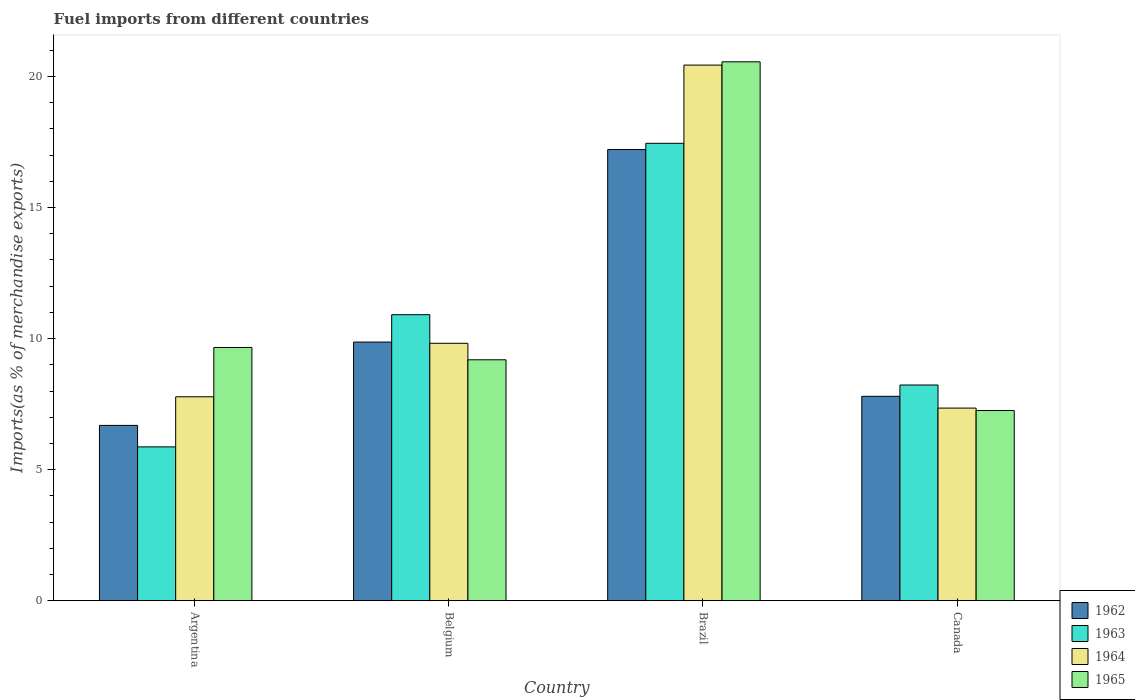How many different coloured bars are there?
Keep it short and to the point. 4. How many bars are there on the 4th tick from the left?
Offer a terse response. 4. What is the label of the 4th group of bars from the left?
Ensure brevity in your answer.  Canada. What is the percentage of imports to different countries in 1963 in Brazil?
Provide a succinct answer. 17.45. Across all countries, what is the maximum percentage of imports to different countries in 1965?
Your response must be concise. 20.55. Across all countries, what is the minimum percentage of imports to different countries in 1965?
Give a very brief answer. 7.26. What is the total percentage of imports to different countries in 1964 in the graph?
Keep it short and to the point. 45.38. What is the difference between the percentage of imports to different countries in 1964 in Argentina and that in Belgium?
Your response must be concise. -2.04. What is the difference between the percentage of imports to different countries in 1964 in Brazil and the percentage of imports to different countries in 1963 in Argentina?
Make the answer very short. 14.56. What is the average percentage of imports to different countries in 1964 per country?
Give a very brief answer. 11.34. What is the difference between the percentage of imports to different countries of/in 1963 and percentage of imports to different countries of/in 1964 in Belgium?
Make the answer very short. 1.09. What is the ratio of the percentage of imports to different countries in 1962 in Belgium to that in Canada?
Provide a short and direct response. 1.27. Is the percentage of imports to different countries in 1963 in Argentina less than that in Belgium?
Ensure brevity in your answer.  Yes. What is the difference between the highest and the second highest percentage of imports to different countries in 1965?
Provide a short and direct response. -10.89. What is the difference between the highest and the lowest percentage of imports to different countries in 1963?
Make the answer very short. 11.58. In how many countries, is the percentage of imports to different countries in 1962 greater than the average percentage of imports to different countries in 1962 taken over all countries?
Keep it short and to the point. 1. What does the 1st bar from the left in Brazil represents?
Provide a short and direct response. 1962. What does the 4th bar from the right in Belgium represents?
Your answer should be compact. 1962. Is it the case that in every country, the sum of the percentage of imports to different countries in 1964 and percentage of imports to different countries in 1965 is greater than the percentage of imports to different countries in 1962?
Provide a succinct answer. Yes. Are all the bars in the graph horizontal?
Give a very brief answer. No. What is the difference between two consecutive major ticks on the Y-axis?
Ensure brevity in your answer.  5. Are the values on the major ticks of Y-axis written in scientific E-notation?
Your answer should be compact. No. Does the graph contain grids?
Provide a short and direct response. No. How many legend labels are there?
Your answer should be very brief. 4. How are the legend labels stacked?
Make the answer very short. Vertical. What is the title of the graph?
Offer a very short reply. Fuel imports from different countries. What is the label or title of the X-axis?
Your response must be concise. Country. What is the label or title of the Y-axis?
Give a very brief answer. Imports(as % of merchandise exports). What is the Imports(as % of merchandise exports) of 1962 in Argentina?
Ensure brevity in your answer.  6.69. What is the Imports(as % of merchandise exports) in 1963 in Argentina?
Your answer should be compact. 5.87. What is the Imports(as % of merchandise exports) in 1964 in Argentina?
Keep it short and to the point. 7.78. What is the Imports(as % of merchandise exports) in 1965 in Argentina?
Your answer should be very brief. 9.66. What is the Imports(as % of merchandise exports) of 1962 in Belgium?
Provide a succinct answer. 9.87. What is the Imports(as % of merchandise exports) in 1963 in Belgium?
Your answer should be compact. 10.91. What is the Imports(as % of merchandise exports) of 1964 in Belgium?
Your answer should be very brief. 9.82. What is the Imports(as % of merchandise exports) in 1965 in Belgium?
Your answer should be compact. 9.19. What is the Imports(as % of merchandise exports) in 1962 in Brazil?
Provide a succinct answer. 17.21. What is the Imports(as % of merchandise exports) in 1963 in Brazil?
Provide a succinct answer. 17.45. What is the Imports(as % of merchandise exports) of 1964 in Brazil?
Your response must be concise. 20.43. What is the Imports(as % of merchandise exports) in 1965 in Brazil?
Offer a very short reply. 20.55. What is the Imports(as % of merchandise exports) in 1962 in Canada?
Offer a terse response. 7.8. What is the Imports(as % of merchandise exports) of 1963 in Canada?
Your answer should be compact. 8.23. What is the Imports(as % of merchandise exports) of 1964 in Canada?
Your answer should be very brief. 7.35. What is the Imports(as % of merchandise exports) in 1965 in Canada?
Keep it short and to the point. 7.26. Across all countries, what is the maximum Imports(as % of merchandise exports) in 1962?
Give a very brief answer. 17.21. Across all countries, what is the maximum Imports(as % of merchandise exports) in 1963?
Your response must be concise. 17.45. Across all countries, what is the maximum Imports(as % of merchandise exports) of 1964?
Your answer should be compact. 20.43. Across all countries, what is the maximum Imports(as % of merchandise exports) of 1965?
Ensure brevity in your answer.  20.55. Across all countries, what is the minimum Imports(as % of merchandise exports) of 1962?
Make the answer very short. 6.69. Across all countries, what is the minimum Imports(as % of merchandise exports) of 1963?
Ensure brevity in your answer.  5.87. Across all countries, what is the minimum Imports(as % of merchandise exports) of 1964?
Provide a succinct answer. 7.35. Across all countries, what is the minimum Imports(as % of merchandise exports) in 1965?
Keep it short and to the point. 7.26. What is the total Imports(as % of merchandise exports) of 1962 in the graph?
Ensure brevity in your answer.  41.56. What is the total Imports(as % of merchandise exports) of 1963 in the graph?
Provide a succinct answer. 42.46. What is the total Imports(as % of merchandise exports) of 1964 in the graph?
Your answer should be compact. 45.38. What is the total Imports(as % of merchandise exports) in 1965 in the graph?
Keep it short and to the point. 46.66. What is the difference between the Imports(as % of merchandise exports) in 1962 in Argentina and that in Belgium?
Your answer should be compact. -3.18. What is the difference between the Imports(as % of merchandise exports) in 1963 in Argentina and that in Belgium?
Provide a succinct answer. -5.04. What is the difference between the Imports(as % of merchandise exports) in 1964 in Argentina and that in Belgium?
Ensure brevity in your answer.  -2.04. What is the difference between the Imports(as % of merchandise exports) of 1965 in Argentina and that in Belgium?
Your answer should be compact. 0.47. What is the difference between the Imports(as % of merchandise exports) of 1962 in Argentina and that in Brazil?
Provide a short and direct response. -10.52. What is the difference between the Imports(as % of merchandise exports) in 1963 in Argentina and that in Brazil?
Your answer should be very brief. -11.58. What is the difference between the Imports(as % of merchandise exports) of 1964 in Argentina and that in Brazil?
Provide a succinct answer. -12.65. What is the difference between the Imports(as % of merchandise exports) in 1965 in Argentina and that in Brazil?
Provide a short and direct response. -10.89. What is the difference between the Imports(as % of merchandise exports) in 1962 in Argentina and that in Canada?
Provide a succinct answer. -1.11. What is the difference between the Imports(as % of merchandise exports) of 1963 in Argentina and that in Canada?
Provide a succinct answer. -2.36. What is the difference between the Imports(as % of merchandise exports) of 1964 in Argentina and that in Canada?
Keep it short and to the point. 0.43. What is the difference between the Imports(as % of merchandise exports) of 1965 in Argentina and that in Canada?
Offer a very short reply. 2.4. What is the difference between the Imports(as % of merchandise exports) in 1962 in Belgium and that in Brazil?
Make the answer very short. -7.34. What is the difference between the Imports(as % of merchandise exports) in 1963 in Belgium and that in Brazil?
Offer a terse response. -6.54. What is the difference between the Imports(as % of merchandise exports) in 1964 in Belgium and that in Brazil?
Ensure brevity in your answer.  -10.61. What is the difference between the Imports(as % of merchandise exports) of 1965 in Belgium and that in Brazil?
Keep it short and to the point. -11.36. What is the difference between the Imports(as % of merchandise exports) in 1962 in Belgium and that in Canada?
Make the answer very short. 2.07. What is the difference between the Imports(as % of merchandise exports) in 1963 in Belgium and that in Canada?
Give a very brief answer. 2.68. What is the difference between the Imports(as % of merchandise exports) in 1964 in Belgium and that in Canada?
Make the answer very short. 2.47. What is the difference between the Imports(as % of merchandise exports) of 1965 in Belgium and that in Canada?
Make the answer very short. 1.93. What is the difference between the Imports(as % of merchandise exports) in 1962 in Brazil and that in Canada?
Your response must be concise. 9.41. What is the difference between the Imports(as % of merchandise exports) of 1963 in Brazil and that in Canada?
Provide a short and direct response. 9.22. What is the difference between the Imports(as % of merchandise exports) of 1964 in Brazil and that in Canada?
Keep it short and to the point. 13.08. What is the difference between the Imports(as % of merchandise exports) of 1965 in Brazil and that in Canada?
Provide a succinct answer. 13.3. What is the difference between the Imports(as % of merchandise exports) in 1962 in Argentina and the Imports(as % of merchandise exports) in 1963 in Belgium?
Make the answer very short. -4.22. What is the difference between the Imports(as % of merchandise exports) of 1962 in Argentina and the Imports(as % of merchandise exports) of 1964 in Belgium?
Your response must be concise. -3.13. What is the difference between the Imports(as % of merchandise exports) of 1962 in Argentina and the Imports(as % of merchandise exports) of 1965 in Belgium?
Provide a succinct answer. -2.5. What is the difference between the Imports(as % of merchandise exports) of 1963 in Argentina and the Imports(as % of merchandise exports) of 1964 in Belgium?
Ensure brevity in your answer.  -3.95. What is the difference between the Imports(as % of merchandise exports) of 1963 in Argentina and the Imports(as % of merchandise exports) of 1965 in Belgium?
Provide a succinct answer. -3.32. What is the difference between the Imports(as % of merchandise exports) of 1964 in Argentina and the Imports(as % of merchandise exports) of 1965 in Belgium?
Make the answer very short. -1.41. What is the difference between the Imports(as % of merchandise exports) of 1962 in Argentina and the Imports(as % of merchandise exports) of 1963 in Brazil?
Your response must be concise. -10.76. What is the difference between the Imports(as % of merchandise exports) in 1962 in Argentina and the Imports(as % of merchandise exports) in 1964 in Brazil?
Give a very brief answer. -13.74. What is the difference between the Imports(as % of merchandise exports) of 1962 in Argentina and the Imports(as % of merchandise exports) of 1965 in Brazil?
Keep it short and to the point. -13.87. What is the difference between the Imports(as % of merchandise exports) of 1963 in Argentina and the Imports(as % of merchandise exports) of 1964 in Brazil?
Your answer should be very brief. -14.56. What is the difference between the Imports(as % of merchandise exports) in 1963 in Argentina and the Imports(as % of merchandise exports) in 1965 in Brazil?
Give a very brief answer. -14.68. What is the difference between the Imports(as % of merchandise exports) in 1964 in Argentina and the Imports(as % of merchandise exports) in 1965 in Brazil?
Your response must be concise. -12.77. What is the difference between the Imports(as % of merchandise exports) in 1962 in Argentina and the Imports(as % of merchandise exports) in 1963 in Canada?
Offer a very short reply. -1.54. What is the difference between the Imports(as % of merchandise exports) in 1962 in Argentina and the Imports(as % of merchandise exports) in 1964 in Canada?
Provide a short and direct response. -0.66. What is the difference between the Imports(as % of merchandise exports) in 1962 in Argentina and the Imports(as % of merchandise exports) in 1965 in Canada?
Give a very brief answer. -0.57. What is the difference between the Imports(as % of merchandise exports) of 1963 in Argentina and the Imports(as % of merchandise exports) of 1964 in Canada?
Your response must be concise. -1.48. What is the difference between the Imports(as % of merchandise exports) of 1963 in Argentina and the Imports(as % of merchandise exports) of 1965 in Canada?
Your answer should be compact. -1.39. What is the difference between the Imports(as % of merchandise exports) of 1964 in Argentina and the Imports(as % of merchandise exports) of 1965 in Canada?
Provide a succinct answer. 0.52. What is the difference between the Imports(as % of merchandise exports) of 1962 in Belgium and the Imports(as % of merchandise exports) of 1963 in Brazil?
Provide a short and direct response. -7.58. What is the difference between the Imports(as % of merchandise exports) of 1962 in Belgium and the Imports(as % of merchandise exports) of 1964 in Brazil?
Your response must be concise. -10.56. What is the difference between the Imports(as % of merchandise exports) of 1962 in Belgium and the Imports(as % of merchandise exports) of 1965 in Brazil?
Provide a short and direct response. -10.69. What is the difference between the Imports(as % of merchandise exports) of 1963 in Belgium and the Imports(as % of merchandise exports) of 1964 in Brazil?
Ensure brevity in your answer.  -9.52. What is the difference between the Imports(as % of merchandise exports) of 1963 in Belgium and the Imports(as % of merchandise exports) of 1965 in Brazil?
Your answer should be compact. -9.64. What is the difference between the Imports(as % of merchandise exports) in 1964 in Belgium and the Imports(as % of merchandise exports) in 1965 in Brazil?
Your answer should be very brief. -10.74. What is the difference between the Imports(as % of merchandise exports) of 1962 in Belgium and the Imports(as % of merchandise exports) of 1963 in Canada?
Provide a short and direct response. 1.64. What is the difference between the Imports(as % of merchandise exports) in 1962 in Belgium and the Imports(as % of merchandise exports) in 1964 in Canada?
Offer a very short reply. 2.52. What is the difference between the Imports(as % of merchandise exports) in 1962 in Belgium and the Imports(as % of merchandise exports) in 1965 in Canada?
Provide a short and direct response. 2.61. What is the difference between the Imports(as % of merchandise exports) of 1963 in Belgium and the Imports(as % of merchandise exports) of 1964 in Canada?
Your response must be concise. 3.56. What is the difference between the Imports(as % of merchandise exports) of 1963 in Belgium and the Imports(as % of merchandise exports) of 1965 in Canada?
Provide a short and direct response. 3.65. What is the difference between the Imports(as % of merchandise exports) of 1964 in Belgium and the Imports(as % of merchandise exports) of 1965 in Canada?
Offer a very short reply. 2.56. What is the difference between the Imports(as % of merchandise exports) of 1962 in Brazil and the Imports(as % of merchandise exports) of 1963 in Canada?
Your answer should be compact. 8.98. What is the difference between the Imports(as % of merchandise exports) of 1962 in Brazil and the Imports(as % of merchandise exports) of 1964 in Canada?
Give a very brief answer. 9.86. What is the difference between the Imports(as % of merchandise exports) in 1962 in Brazil and the Imports(as % of merchandise exports) in 1965 in Canada?
Keep it short and to the point. 9.95. What is the difference between the Imports(as % of merchandise exports) of 1963 in Brazil and the Imports(as % of merchandise exports) of 1964 in Canada?
Give a very brief answer. 10.1. What is the difference between the Imports(as % of merchandise exports) in 1963 in Brazil and the Imports(as % of merchandise exports) in 1965 in Canada?
Keep it short and to the point. 10.19. What is the difference between the Imports(as % of merchandise exports) of 1964 in Brazil and the Imports(as % of merchandise exports) of 1965 in Canada?
Your answer should be very brief. 13.17. What is the average Imports(as % of merchandise exports) in 1962 per country?
Your response must be concise. 10.39. What is the average Imports(as % of merchandise exports) in 1963 per country?
Keep it short and to the point. 10.61. What is the average Imports(as % of merchandise exports) in 1964 per country?
Your answer should be compact. 11.34. What is the average Imports(as % of merchandise exports) of 1965 per country?
Give a very brief answer. 11.67. What is the difference between the Imports(as % of merchandise exports) of 1962 and Imports(as % of merchandise exports) of 1963 in Argentina?
Provide a succinct answer. 0.82. What is the difference between the Imports(as % of merchandise exports) in 1962 and Imports(as % of merchandise exports) in 1964 in Argentina?
Offer a terse response. -1.09. What is the difference between the Imports(as % of merchandise exports) of 1962 and Imports(as % of merchandise exports) of 1965 in Argentina?
Your answer should be compact. -2.97. What is the difference between the Imports(as % of merchandise exports) in 1963 and Imports(as % of merchandise exports) in 1964 in Argentina?
Give a very brief answer. -1.91. What is the difference between the Imports(as % of merchandise exports) in 1963 and Imports(as % of merchandise exports) in 1965 in Argentina?
Offer a very short reply. -3.79. What is the difference between the Imports(as % of merchandise exports) of 1964 and Imports(as % of merchandise exports) of 1965 in Argentina?
Offer a terse response. -1.88. What is the difference between the Imports(as % of merchandise exports) in 1962 and Imports(as % of merchandise exports) in 1963 in Belgium?
Your response must be concise. -1.04. What is the difference between the Imports(as % of merchandise exports) in 1962 and Imports(as % of merchandise exports) in 1964 in Belgium?
Your answer should be compact. 0.05. What is the difference between the Imports(as % of merchandise exports) of 1962 and Imports(as % of merchandise exports) of 1965 in Belgium?
Your answer should be very brief. 0.68. What is the difference between the Imports(as % of merchandise exports) in 1963 and Imports(as % of merchandise exports) in 1964 in Belgium?
Offer a very short reply. 1.09. What is the difference between the Imports(as % of merchandise exports) in 1963 and Imports(as % of merchandise exports) in 1965 in Belgium?
Offer a very short reply. 1.72. What is the difference between the Imports(as % of merchandise exports) in 1964 and Imports(as % of merchandise exports) in 1965 in Belgium?
Your response must be concise. 0.63. What is the difference between the Imports(as % of merchandise exports) in 1962 and Imports(as % of merchandise exports) in 1963 in Brazil?
Make the answer very short. -0.24. What is the difference between the Imports(as % of merchandise exports) of 1962 and Imports(as % of merchandise exports) of 1964 in Brazil?
Your answer should be very brief. -3.22. What is the difference between the Imports(as % of merchandise exports) of 1962 and Imports(as % of merchandise exports) of 1965 in Brazil?
Give a very brief answer. -3.35. What is the difference between the Imports(as % of merchandise exports) in 1963 and Imports(as % of merchandise exports) in 1964 in Brazil?
Provide a short and direct response. -2.98. What is the difference between the Imports(as % of merchandise exports) of 1963 and Imports(as % of merchandise exports) of 1965 in Brazil?
Make the answer very short. -3.11. What is the difference between the Imports(as % of merchandise exports) of 1964 and Imports(as % of merchandise exports) of 1965 in Brazil?
Offer a very short reply. -0.12. What is the difference between the Imports(as % of merchandise exports) of 1962 and Imports(as % of merchandise exports) of 1963 in Canada?
Offer a very short reply. -0.43. What is the difference between the Imports(as % of merchandise exports) in 1962 and Imports(as % of merchandise exports) in 1964 in Canada?
Your response must be concise. 0.45. What is the difference between the Imports(as % of merchandise exports) in 1962 and Imports(as % of merchandise exports) in 1965 in Canada?
Your answer should be very brief. 0.54. What is the difference between the Imports(as % of merchandise exports) of 1963 and Imports(as % of merchandise exports) of 1964 in Canada?
Make the answer very short. 0.88. What is the difference between the Imports(as % of merchandise exports) of 1963 and Imports(as % of merchandise exports) of 1965 in Canada?
Your answer should be compact. 0.97. What is the difference between the Imports(as % of merchandise exports) of 1964 and Imports(as % of merchandise exports) of 1965 in Canada?
Make the answer very short. 0.09. What is the ratio of the Imports(as % of merchandise exports) of 1962 in Argentina to that in Belgium?
Your response must be concise. 0.68. What is the ratio of the Imports(as % of merchandise exports) of 1963 in Argentina to that in Belgium?
Give a very brief answer. 0.54. What is the ratio of the Imports(as % of merchandise exports) in 1964 in Argentina to that in Belgium?
Make the answer very short. 0.79. What is the ratio of the Imports(as % of merchandise exports) of 1965 in Argentina to that in Belgium?
Your answer should be very brief. 1.05. What is the ratio of the Imports(as % of merchandise exports) in 1962 in Argentina to that in Brazil?
Your answer should be compact. 0.39. What is the ratio of the Imports(as % of merchandise exports) of 1963 in Argentina to that in Brazil?
Provide a short and direct response. 0.34. What is the ratio of the Imports(as % of merchandise exports) of 1964 in Argentina to that in Brazil?
Offer a very short reply. 0.38. What is the ratio of the Imports(as % of merchandise exports) of 1965 in Argentina to that in Brazil?
Your answer should be compact. 0.47. What is the ratio of the Imports(as % of merchandise exports) in 1962 in Argentina to that in Canada?
Offer a terse response. 0.86. What is the ratio of the Imports(as % of merchandise exports) in 1963 in Argentina to that in Canada?
Offer a very short reply. 0.71. What is the ratio of the Imports(as % of merchandise exports) of 1964 in Argentina to that in Canada?
Offer a terse response. 1.06. What is the ratio of the Imports(as % of merchandise exports) in 1965 in Argentina to that in Canada?
Your response must be concise. 1.33. What is the ratio of the Imports(as % of merchandise exports) of 1962 in Belgium to that in Brazil?
Give a very brief answer. 0.57. What is the ratio of the Imports(as % of merchandise exports) in 1963 in Belgium to that in Brazil?
Your answer should be compact. 0.63. What is the ratio of the Imports(as % of merchandise exports) of 1964 in Belgium to that in Brazil?
Keep it short and to the point. 0.48. What is the ratio of the Imports(as % of merchandise exports) of 1965 in Belgium to that in Brazil?
Give a very brief answer. 0.45. What is the ratio of the Imports(as % of merchandise exports) of 1962 in Belgium to that in Canada?
Provide a succinct answer. 1.27. What is the ratio of the Imports(as % of merchandise exports) of 1963 in Belgium to that in Canada?
Make the answer very short. 1.33. What is the ratio of the Imports(as % of merchandise exports) in 1964 in Belgium to that in Canada?
Keep it short and to the point. 1.34. What is the ratio of the Imports(as % of merchandise exports) of 1965 in Belgium to that in Canada?
Give a very brief answer. 1.27. What is the ratio of the Imports(as % of merchandise exports) of 1962 in Brazil to that in Canada?
Your response must be concise. 2.21. What is the ratio of the Imports(as % of merchandise exports) of 1963 in Brazil to that in Canada?
Your response must be concise. 2.12. What is the ratio of the Imports(as % of merchandise exports) of 1964 in Brazil to that in Canada?
Ensure brevity in your answer.  2.78. What is the ratio of the Imports(as % of merchandise exports) of 1965 in Brazil to that in Canada?
Provide a short and direct response. 2.83. What is the difference between the highest and the second highest Imports(as % of merchandise exports) in 1962?
Provide a short and direct response. 7.34. What is the difference between the highest and the second highest Imports(as % of merchandise exports) in 1963?
Keep it short and to the point. 6.54. What is the difference between the highest and the second highest Imports(as % of merchandise exports) in 1964?
Ensure brevity in your answer.  10.61. What is the difference between the highest and the second highest Imports(as % of merchandise exports) of 1965?
Give a very brief answer. 10.89. What is the difference between the highest and the lowest Imports(as % of merchandise exports) in 1962?
Offer a very short reply. 10.52. What is the difference between the highest and the lowest Imports(as % of merchandise exports) in 1963?
Your response must be concise. 11.58. What is the difference between the highest and the lowest Imports(as % of merchandise exports) in 1964?
Provide a short and direct response. 13.08. What is the difference between the highest and the lowest Imports(as % of merchandise exports) of 1965?
Provide a short and direct response. 13.3. 